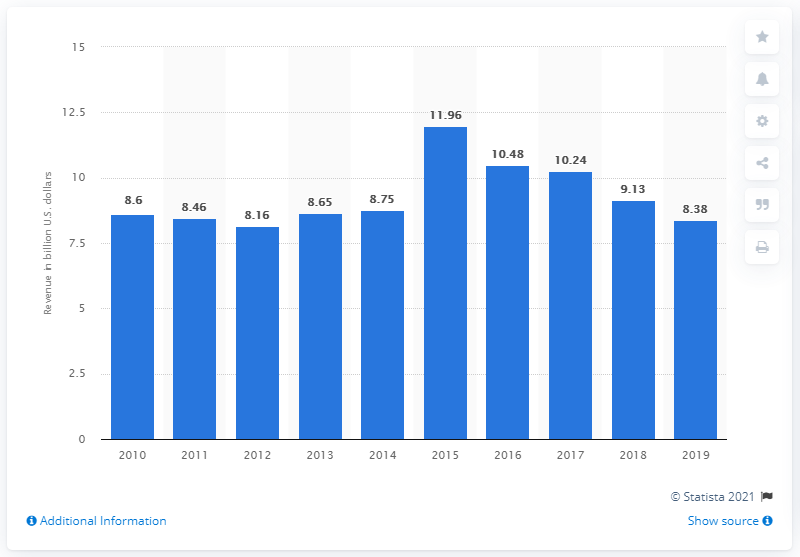Outline some significant characteristics in this image. In the year 2019, the U.S. book publishing industry generated the lowest annual revenue of textbooks. In 2019, the revenue of the U.S. book publishing industry was $8.38 billion. In 2018, the book publishing industry in the United States generated a total revenue of approximately 9.13 billion dollars. 